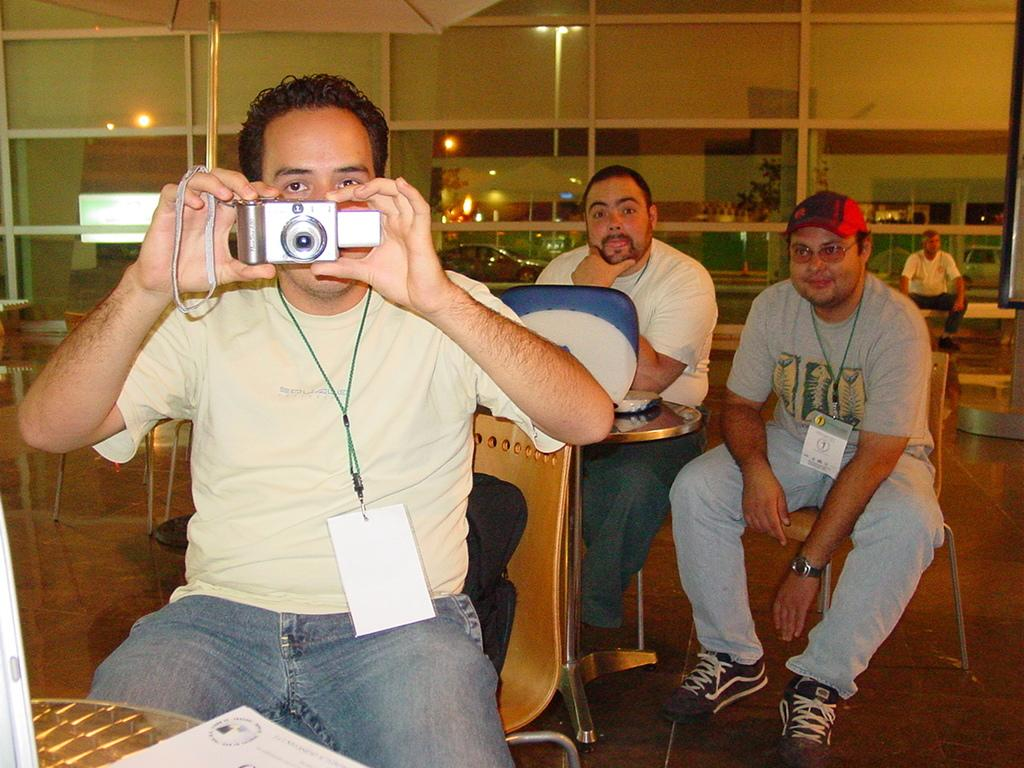What are the men in the image doing? The men are sitting on a table in the image. Can you describe what one of the men is holding? One of the men is holding a camera. What is the man with the camera doing? The man with the camera is capturing something behind a glass wall. How many giants can be seen in the image? There are no giants present in the image. What type of house is visible behind the glass wall? There is no house visible in the image; only something behind a glass wall is mentioned. 